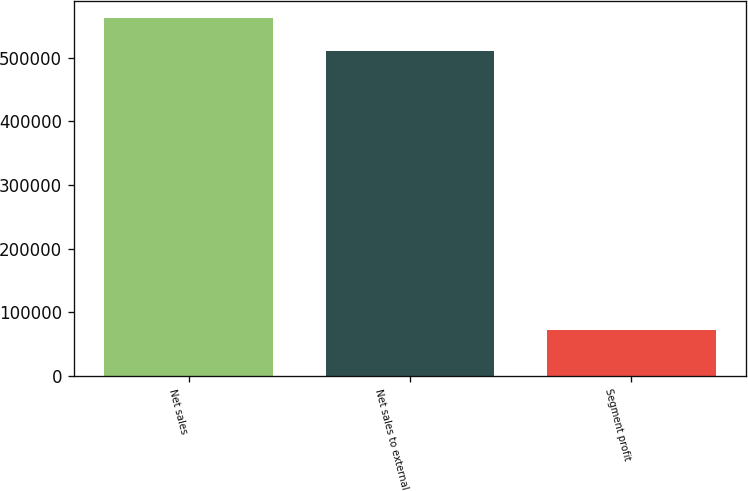Convert chart to OTSL. <chart><loc_0><loc_0><loc_500><loc_500><bar_chart><fcel>Net sales<fcel>Net sales to external<fcel>Segment profit<nl><fcel>561435<fcel>510609<fcel>72682<nl></chart> 